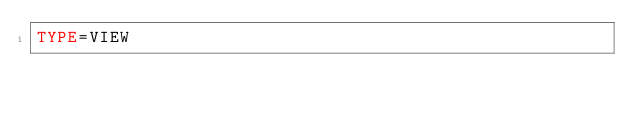Convert code to text. <code><loc_0><loc_0><loc_500><loc_500><_VisualBasic_>TYPE=VIEW</code> 